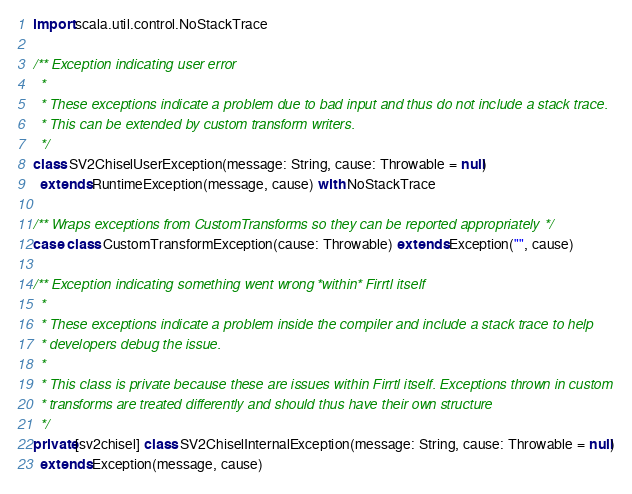<code> <loc_0><loc_0><loc_500><loc_500><_Scala_>
import scala.util.control.NoStackTrace

/** Exception indicating user error
  *
  * These exceptions indicate a problem due to bad input and thus do not include a stack trace.
  * This can be extended by custom transform writers.
  */
class SV2ChiselUserException(message: String, cause: Throwable = null)
  extends RuntimeException(message, cause) with NoStackTrace

/** Wraps exceptions from CustomTransforms so they can be reported appropriately */
case class CustomTransformException(cause: Throwable) extends Exception("", cause)

/** Exception indicating something went wrong *within* Firrtl itself
  *
  * These exceptions indicate a problem inside the compiler and include a stack trace to help
  * developers debug the issue.
  *
  * This class is private because these are issues within Firrtl itself. Exceptions thrown in custom
  * transforms are treated differently and should thus have their own structure
  */
private[sv2chisel] class SV2ChiselInternalException(message: String, cause: Throwable = null)
  extends Exception(message, cause)
</code> 